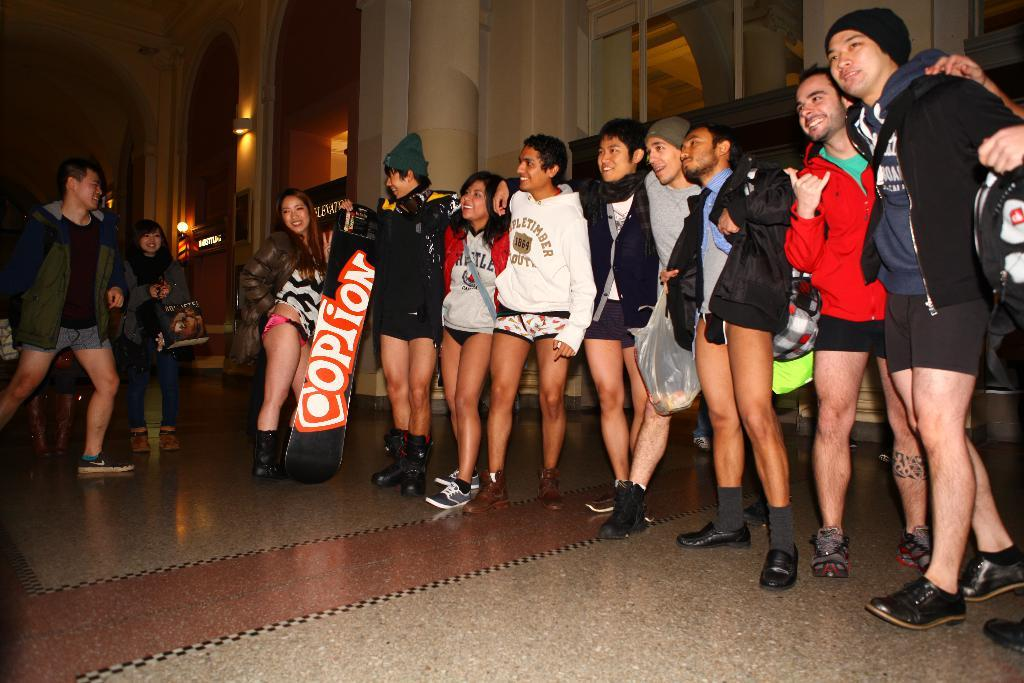Provide a one-sentence caption for the provided image. A board that says option is help up by a man standing in a row. 